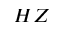Convert formula to latex. <formula><loc_0><loc_0><loc_500><loc_500>H Z</formula> 